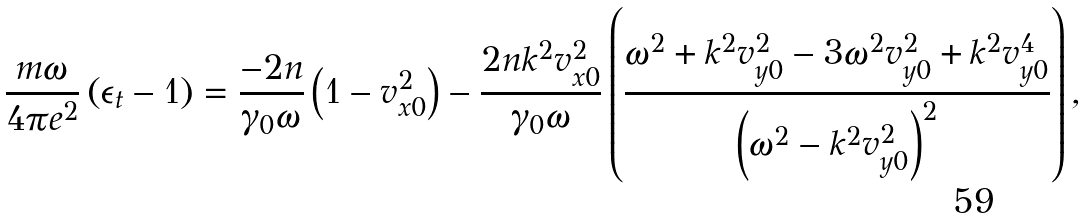<formula> <loc_0><loc_0><loc_500><loc_500>\frac { m \omega } { 4 \pi e ^ { 2 } } \left ( \epsilon _ { t } - 1 \right ) = \frac { - 2 n } { \gamma _ { 0 } \omega } \left ( 1 - v _ { x 0 } ^ { 2 } \right ) - \frac { 2 n k ^ { 2 } v _ { x 0 } ^ { 2 } } { \gamma _ { 0 } \omega } \left ( \frac { \omega ^ { 2 } + k ^ { 2 } v _ { y 0 } ^ { 2 } - 3 \omega ^ { 2 } v _ { y 0 } ^ { 2 } + k ^ { 2 } v _ { y 0 } ^ { 4 } } { \left ( \omega ^ { 2 } - k ^ { 2 } v _ { y 0 } ^ { 2 } \right ) ^ { 2 } } \right ) ,</formula> 